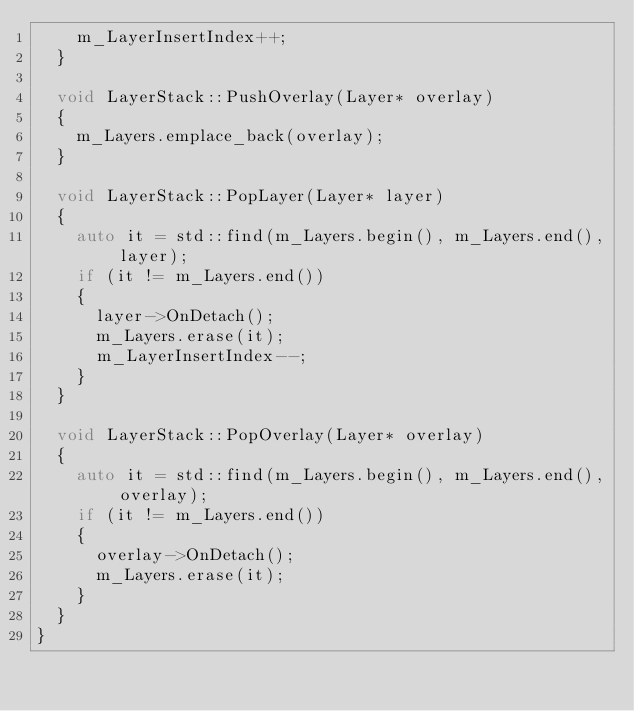Convert code to text. <code><loc_0><loc_0><loc_500><loc_500><_C++_>		m_LayerInsertIndex++;
	}

	void LayerStack::PushOverlay(Layer* overlay)
	{
		m_Layers.emplace_back(overlay);
	}

	void LayerStack::PopLayer(Layer* layer)
	{
		auto it = std::find(m_Layers.begin(), m_Layers.end(), layer);
		if (it != m_Layers.end())
		{
			layer->OnDetach();
			m_Layers.erase(it);
			m_LayerInsertIndex--;
		}
	}

	void LayerStack::PopOverlay(Layer* overlay)
	{
		auto it = std::find(m_Layers.begin(), m_Layers.end(), overlay);
		if (it != m_Layers.end()) 
		{
			overlay->OnDetach();
			m_Layers.erase(it);
		}
	}
}
</code> 